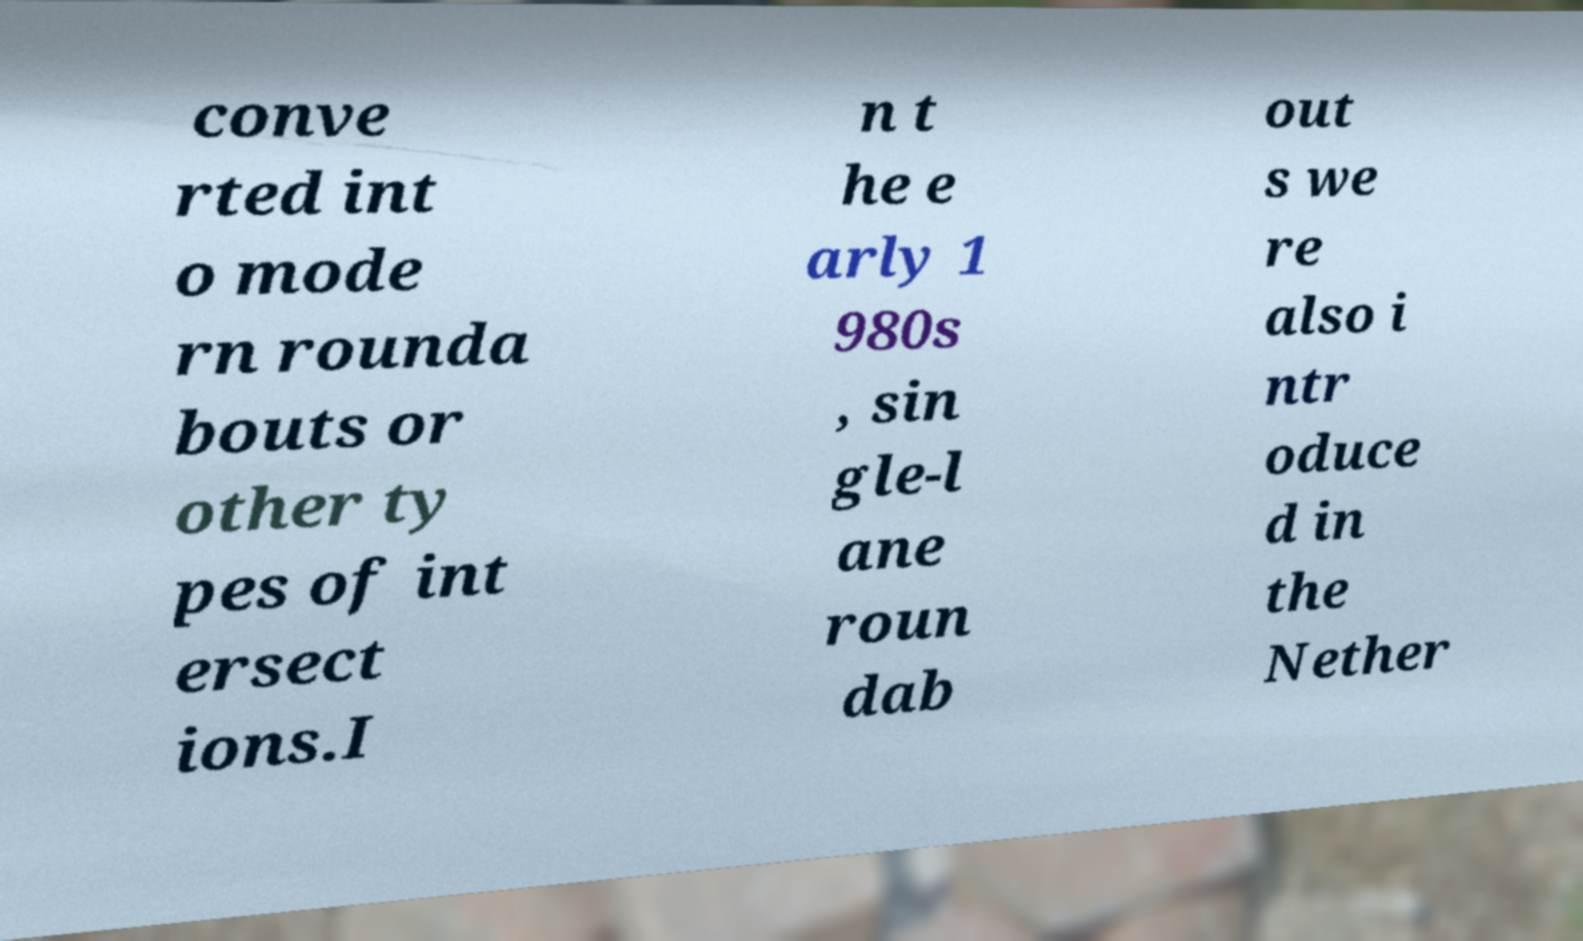I need the written content from this picture converted into text. Can you do that? conve rted int o mode rn rounda bouts or other ty pes of int ersect ions.I n t he e arly 1 980s , sin gle-l ane roun dab out s we re also i ntr oduce d in the Nether 